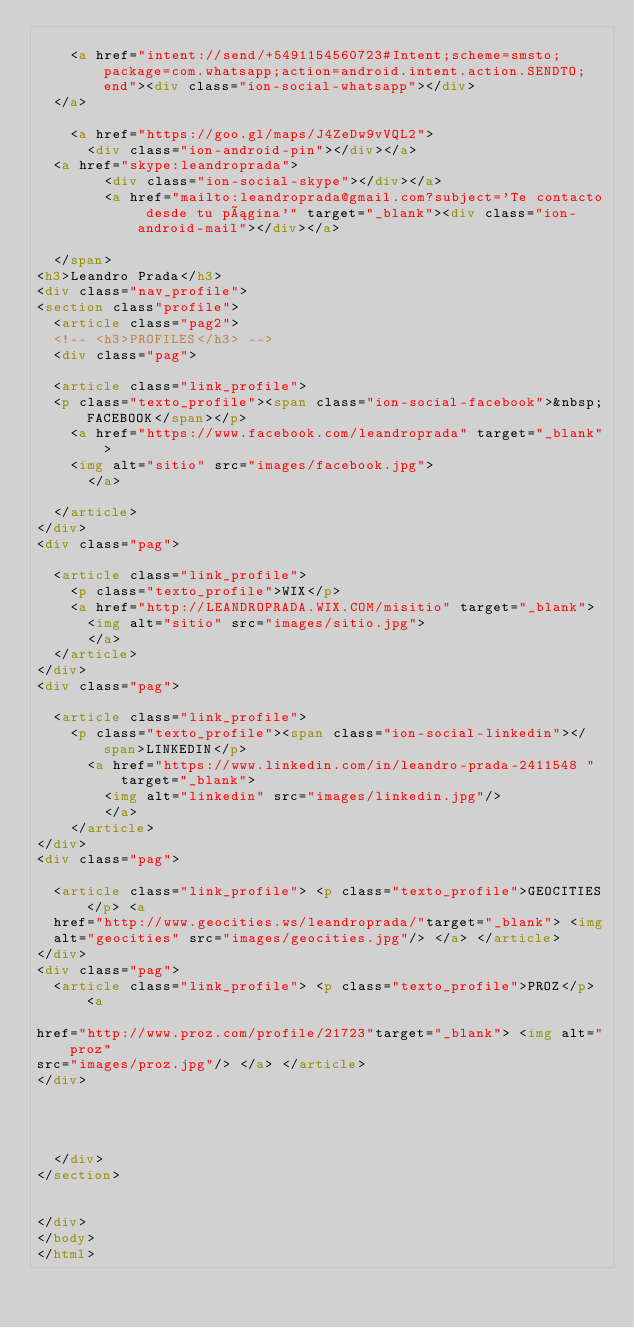<code> <loc_0><loc_0><loc_500><loc_500><_HTML_>
    <a href="intent://send/+5491154560723#Intent;scheme=smsto;package=com.whatsapp;action=android.intent.action.SENDTO;end"><div class="ion-social-whatsapp"></div>
  </a>

    <a href="https://goo.gl/maps/J4ZeDw9vVQL2">
      <div class="ion-android-pin"></div></a>
  <a href="skype:leandroprada">
        <div class="ion-social-skype"></div></a>
        <a href="mailto:leandroprada@gmail.com?subject='Te contacto desde tu página'" target="_blank"><div class="ion-android-mail"></div></a>

  </span>
<h3>Leandro Prada</h3>
<div class="nav_profile">
<section class"profile">
  <article class="pag2">
  <!-- <h3>PROFILES</h3> -->
  <div class="pag">

  <article class="link_profile">
  <p class="texto_profile"><span class="ion-social-facebook">&nbsp;FACEBOOK</span></p>
    <a href="https://www.facebook.com/leandroprada" target="_blank">
    <img alt="sitio" src="images/facebook.jpg">
      </a>

  </article>
</div>
<div class="pag">

  <article class="link_profile">
    <p class="texto_profile">WIX</p>
    <a href="http://LEANDROPRADA.WIX.COM/misitio" target="_blank">
      <img alt="sitio" src="images/sitio.jpg">
      </a>
  </article>
</div>
<div class="pag">

  <article class="link_profile">
    <p class="texto_profile"><span class="ion-social-linkedin"></span>LINKEDIN</p>
      <a href="https://www.linkedin.com/in/leandro-prada-2411548 "target="_blank">
        <img alt="linkedin" src="images/linkedin.jpg"/>
        </a>
    </article>
</div>
<div class="pag">

  <article class="link_profile"> <p class="texto_profile">GEOCITIES</p> <a
  href="http://www.geocities.ws/leandroprada/"target="_blank"> <img
  alt="geocities" src="images/geocities.jpg"/> </a> </article>
</div>
<div class="pag">
  <article class="link_profile"> <p class="texto_profile">PROZ</p> <a

href="http://www.proz.com/profile/21723"target="_blank"> <img alt="proz"
src="images/proz.jpg"/> </a> </article>
</div>




  </div>
</section>


</div>
</body>
</html>
</code> 